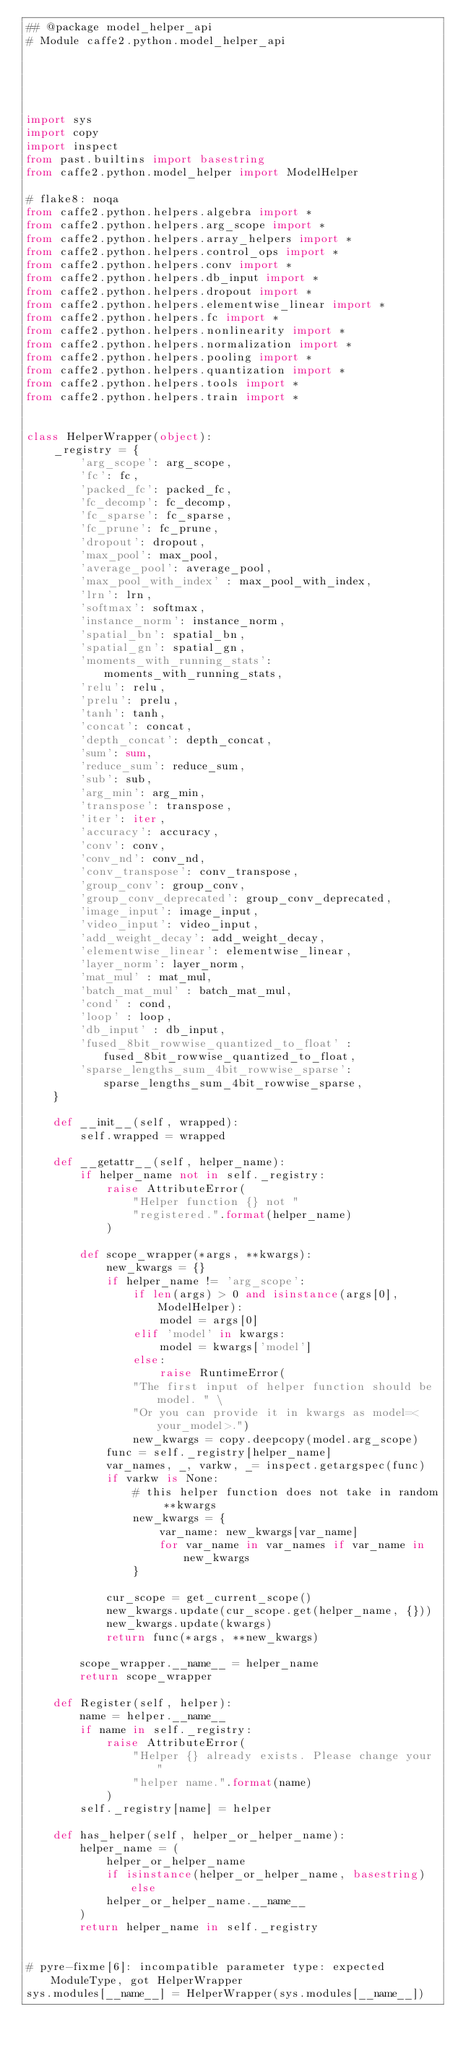<code> <loc_0><loc_0><loc_500><loc_500><_Python_>## @package model_helper_api
# Module caffe2.python.model_helper_api





import sys
import copy
import inspect
from past.builtins import basestring
from caffe2.python.model_helper import ModelHelper

# flake8: noqa
from caffe2.python.helpers.algebra import *
from caffe2.python.helpers.arg_scope import *
from caffe2.python.helpers.array_helpers import *
from caffe2.python.helpers.control_ops import *
from caffe2.python.helpers.conv import *
from caffe2.python.helpers.db_input import *
from caffe2.python.helpers.dropout import *
from caffe2.python.helpers.elementwise_linear import *
from caffe2.python.helpers.fc import *
from caffe2.python.helpers.nonlinearity import *
from caffe2.python.helpers.normalization import *
from caffe2.python.helpers.pooling import *
from caffe2.python.helpers.quantization import *
from caffe2.python.helpers.tools import *
from caffe2.python.helpers.train import *


class HelperWrapper(object):
    _registry = {
        'arg_scope': arg_scope,
        'fc': fc,
        'packed_fc': packed_fc,
        'fc_decomp': fc_decomp,
        'fc_sparse': fc_sparse,
        'fc_prune': fc_prune,
        'dropout': dropout,
        'max_pool': max_pool,
        'average_pool': average_pool,
        'max_pool_with_index' : max_pool_with_index,
        'lrn': lrn,
        'softmax': softmax,
        'instance_norm': instance_norm,
        'spatial_bn': spatial_bn,
        'spatial_gn': spatial_gn,
        'moments_with_running_stats': moments_with_running_stats,
        'relu': relu,
        'prelu': prelu,
        'tanh': tanh,
        'concat': concat,
        'depth_concat': depth_concat,
        'sum': sum,
        'reduce_sum': reduce_sum,
        'sub': sub,
        'arg_min': arg_min,
        'transpose': transpose,
        'iter': iter,
        'accuracy': accuracy,
        'conv': conv,
        'conv_nd': conv_nd,
        'conv_transpose': conv_transpose,
        'group_conv': group_conv,
        'group_conv_deprecated': group_conv_deprecated,
        'image_input': image_input,
        'video_input': video_input,
        'add_weight_decay': add_weight_decay,
        'elementwise_linear': elementwise_linear,
        'layer_norm': layer_norm,
        'mat_mul' : mat_mul,
        'batch_mat_mul' : batch_mat_mul,
        'cond' : cond,
        'loop' : loop,
        'db_input' : db_input,
        'fused_8bit_rowwise_quantized_to_float' : fused_8bit_rowwise_quantized_to_float,
        'sparse_lengths_sum_4bit_rowwise_sparse': sparse_lengths_sum_4bit_rowwise_sparse,
    }

    def __init__(self, wrapped):
        self.wrapped = wrapped

    def __getattr__(self, helper_name):
        if helper_name not in self._registry:
            raise AttributeError(
                "Helper function {} not "
                "registered.".format(helper_name)
            )

        def scope_wrapper(*args, **kwargs):
            new_kwargs = {}
            if helper_name != 'arg_scope':
                if len(args) > 0 and isinstance(args[0], ModelHelper):
                    model = args[0]
                elif 'model' in kwargs:
                    model = kwargs['model']
                else:
                    raise RuntimeError(
                "The first input of helper function should be model. " \
                "Or you can provide it in kwargs as model=<your_model>.")
                new_kwargs = copy.deepcopy(model.arg_scope)
            func = self._registry[helper_name]
            var_names, _, varkw, _= inspect.getargspec(func)
            if varkw is None:
                # this helper function does not take in random **kwargs
                new_kwargs = {
                    var_name: new_kwargs[var_name]
                    for var_name in var_names if var_name in new_kwargs
                }

            cur_scope = get_current_scope()
            new_kwargs.update(cur_scope.get(helper_name, {}))
            new_kwargs.update(kwargs)
            return func(*args, **new_kwargs)

        scope_wrapper.__name__ = helper_name
        return scope_wrapper

    def Register(self, helper):
        name = helper.__name__
        if name in self._registry:
            raise AttributeError(
                "Helper {} already exists. Please change your "
                "helper name.".format(name)
            )
        self._registry[name] = helper

    def has_helper(self, helper_or_helper_name):
        helper_name = (
            helper_or_helper_name
            if isinstance(helper_or_helper_name, basestring) else
            helper_or_helper_name.__name__
        )
        return helper_name in self._registry


# pyre-fixme[6]: incompatible parameter type: expected ModuleType, got HelperWrapper
sys.modules[__name__] = HelperWrapper(sys.modules[__name__])
</code> 